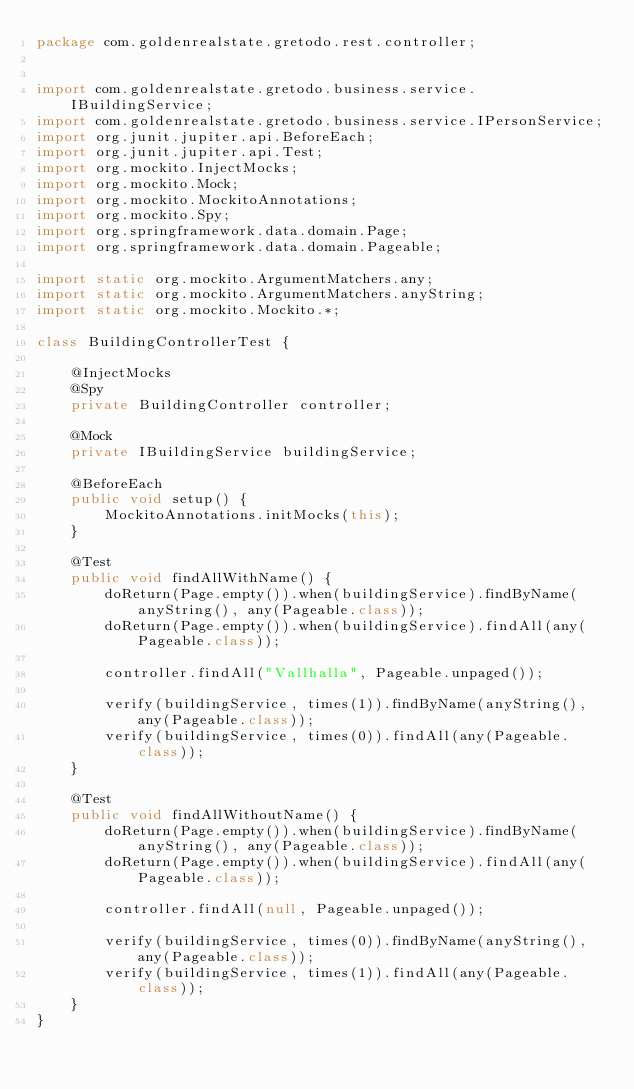Convert code to text. <code><loc_0><loc_0><loc_500><loc_500><_Java_>package com.goldenrealstate.gretodo.rest.controller;


import com.goldenrealstate.gretodo.business.service.IBuildingService;
import com.goldenrealstate.gretodo.business.service.IPersonService;
import org.junit.jupiter.api.BeforeEach;
import org.junit.jupiter.api.Test;
import org.mockito.InjectMocks;
import org.mockito.Mock;
import org.mockito.MockitoAnnotations;
import org.mockito.Spy;
import org.springframework.data.domain.Page;
import org.springframework.data.domain.Pageable;

import static org.mockito.ArgumentMatchers.any;
import static org.mockito.ArgumentMatchers.anyString;
import static org.mockito.Mockito.*;

class BuildingControllerTest {

    @InjectMocks
    @Spy
    private BuildingController controller;

    @Mock
    private IBuildingService buildingService;

    @BeforeEach
    public void setup() {
        MockitoAnnotations.initMocks(this);
    }

    @Test
    public void findAllWithName() {
        doReturn(Page.empty()).when(buildingService).findByName(anyString(), any(Pageable.class));
        doReturn(Page.empty()).when(buildingService).findAll(any(Pageable.class));

        controller.findAll("Vallhalla", Pageable.unpaged());

        verify(buildingService, times(1)).findByName(anyString(), any(Pageable.class));
        verify(buildingService, times(0)).findAll(any(Pageable.class));
    }

    @Test
    public void findAllWithoutName() {
        doReturn(Page.empty()).when(buildingService).findByName(anyString(), any(Pageable.class));
        doReturn(Page.empty()).when(buildingService).findAll(any(Pageable.class));

        controller.findAll(null, Pageable.unpaged());

        verify(buildingService, times(0)).findByName(anyString(), any(Pageable.class));
        verify(buildingService, times(1)).findAll(any(Pageable.class));
    }
}</code> 